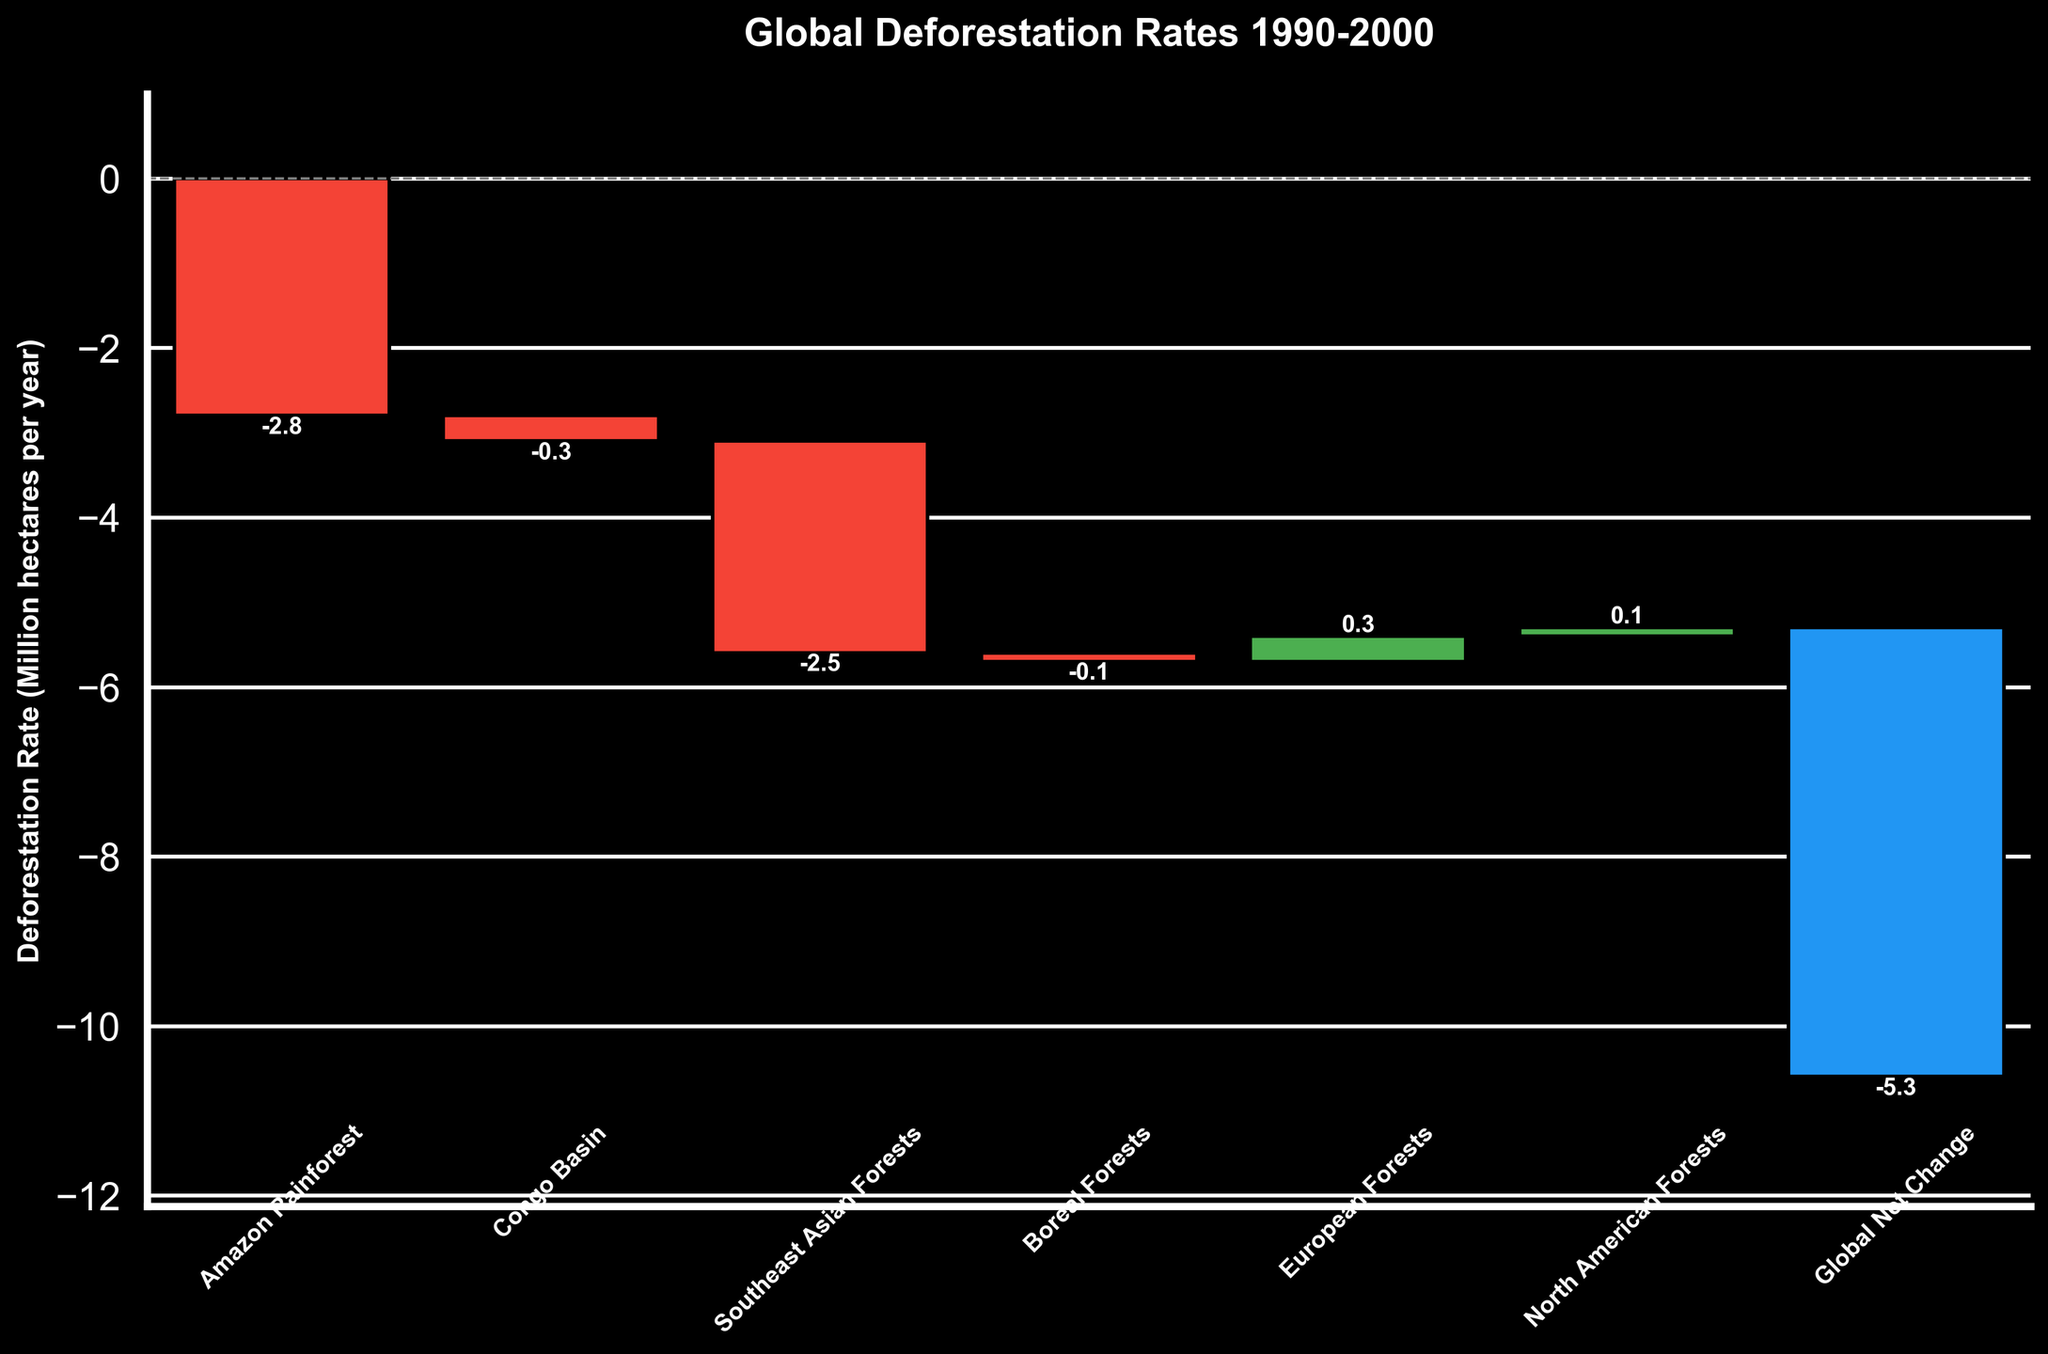what is the title of the figure? The title of the figure is written at the top of the waterfall chart. It is in bold and relatively larger font size compared to the other text.
Answer: Global Deforestation Rates 1990-2000 What region has the highest deforestation rate in the 1990-2000 period? First, examine the length of the bars in the waterfall chart. The region with the longest negative bar represents the highest deforestation rate in the 1990-2000 period.
Answer: Amazon Rainforest Which regions experienced a decrease in deforestation rates between 1990-2000 and 2010-2020? Look at the bars for each region and compare their heights from 1990-2000 to 2010-2020. Regions with smaller negative bars or positive bars in the latter period indicate a decrease in deforestation rates.
Answer: Amazon Rainforest, Southeast Asian Forests What's the total deforestation rate for the Amazon Rainforest between 1990 and 2020? Add the values of deforestation rates for the Amazon Rainforest for each of the three periods: -2.8 + -2.1 + -1.5 = -6.4.
Answer: -6.4 How does the deforestation rate in Boreal Forests compare to that in European Forests from 1990 to 2000? Compare the heights of the bars for Boreal Forests and European Forests in the period 1990-2000. The Boreal Forests have a small negative bar while European Forests have a small positive bar.
Answer: Boreal Forests: -0.1, European Forests: 0.3 What is the deforestation trend for the Global Net Change over the three periods? Look at the bars representing the Global Net Change for each period and observe if the bars are getting smaller, larger, or staying the same. The bars should be getting smaller over time, indicating a decreasing trend.
Answer: Decreasing trend What's the overall net change in deforestation rates from 1990-2000 for all regions combined? Add up all the deforestation rates for each region in the period 1990-2000: -2.8 + -0.3 + -2.5 + -0.1 + 0.3 + 0.1 = -5.3.
Answer: -5.3 Which regions have a positive change in deforestation rates in the 1990-2000 period? Identify the bars that are above the baseline (0) in the waterfall chart for the 1990-2000 period.
Answer: European Forests, North American Forests By how much did the deforestation rate in the Amazon Rainforest decrease from 1990-2000 to 2000-2010? Subtract the deforestation rate for 2000-2010 from the rate for 1990-2000 for the Amazon Rainforest regions: -2.8 - (-2.1) = -0.7.
Answer: 0.7 Compare the deforestation rates between Southeast Asian Forests and Congo Basin from 1990-2020. Examine the bars for Southeast Asian Forests and Congo Basin over each period and compare their values. Calculate the total for each: Southeast Asian Forests: -2.5 - 1.8 - 1.2 = -5.5; Congo Basin: -0.3 - 0.2 - 0.3 = -0.8.
Answer: Southeast Asian Forests: -5.5, Congo Basin: -0.8 